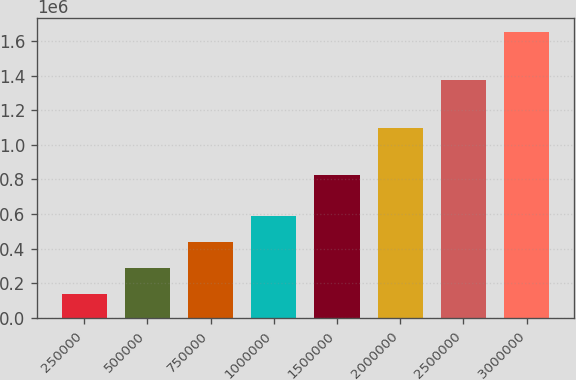Convert chart. <chart><loc_0><loc_0><loc_500><loc_500><bar_chart><fcel>250000<fcel>500000<fcel>750000<fcel>1000000<fcel>1500000<fcel>2000000<fcel>2500000<fcel>3000000<nl><fcel>137500<fcel>288750<fcel>440000<fcel>591250<fcel>825000<fcel>1.1e+06<fcel>1.375e+06<fcel>1.65e+06<nl></chart> 